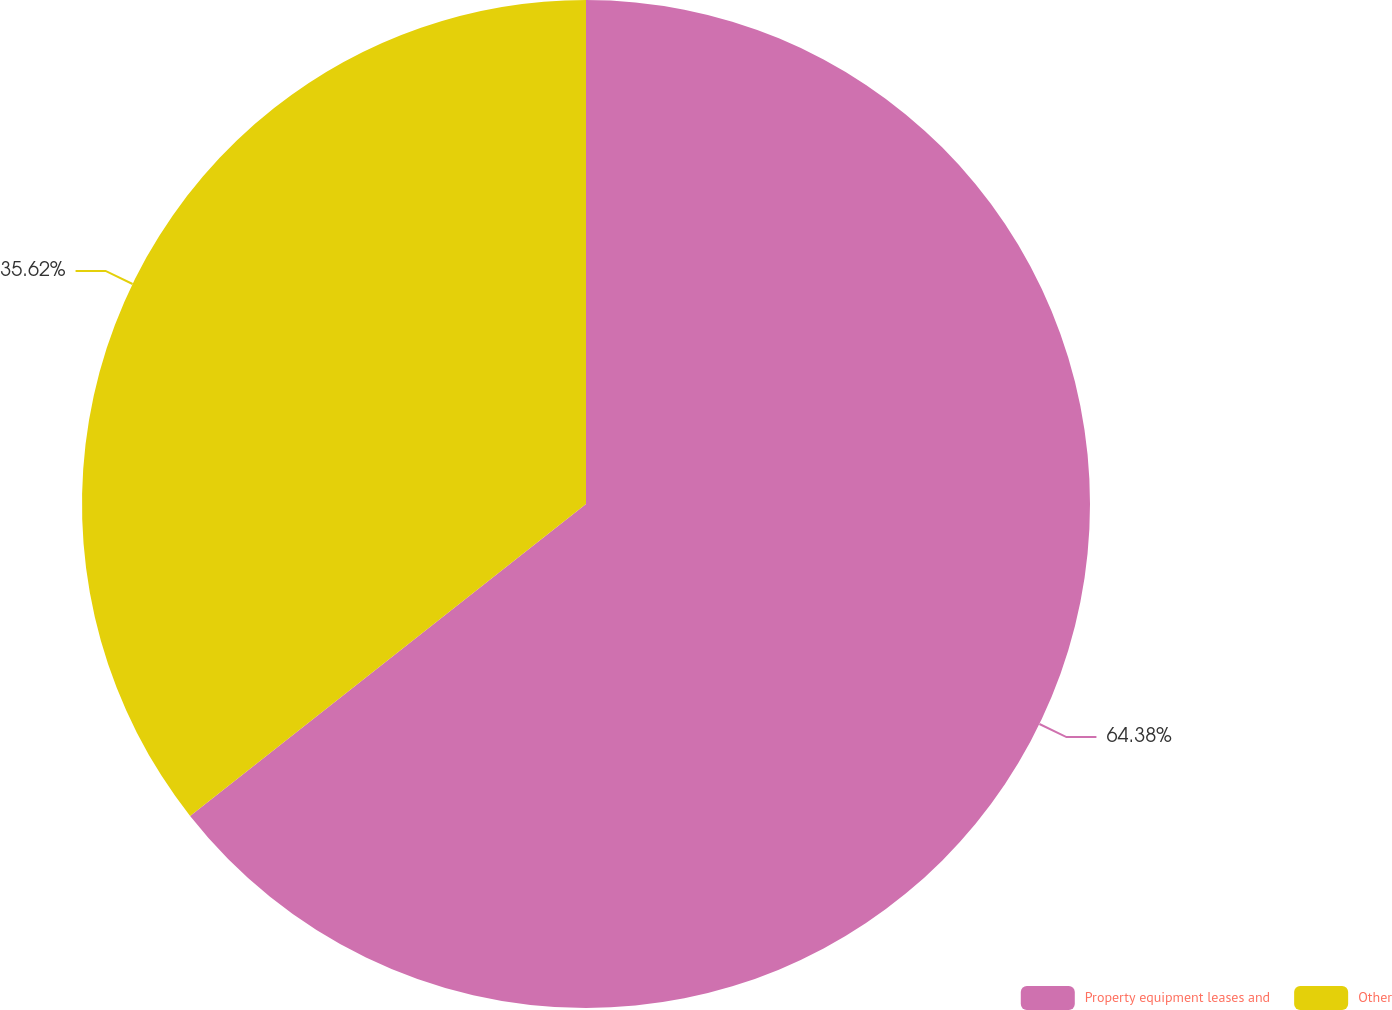Convert chart. <chart><loc_0><loc_0><loc_500><loc_500><pie_chart><fcel>Property equipment leases and<fcel>Other<nl><fcel>64.38%<fcel>35.62%<nl></chart> 